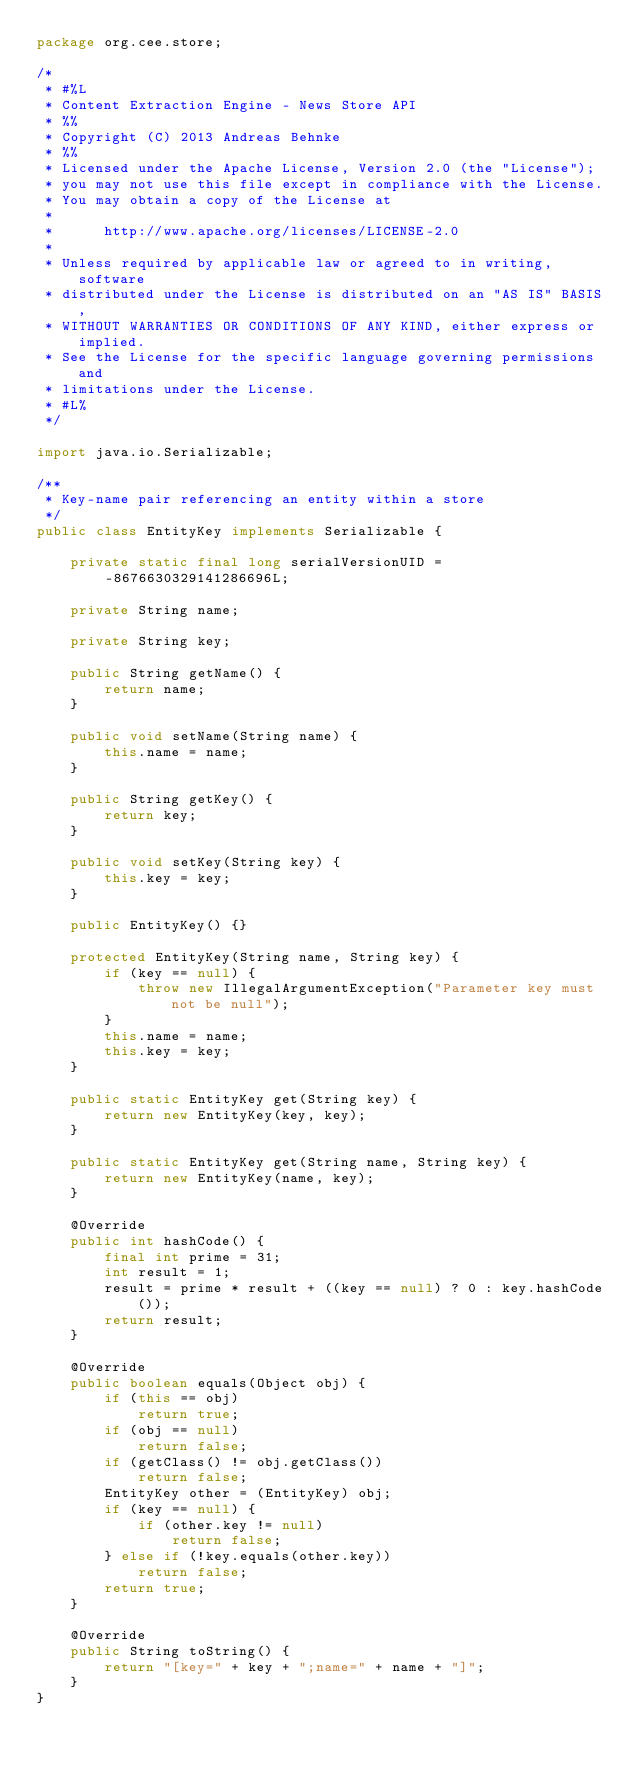Convert code to text. <code><loc_0><loc_0><loc_500><loc_500><_Java_>package org.cee.store;

/*
 * #%L
 * Content Extraction Engine - News Store API
 * %%
 * Copyright (C) 2013 Andreas Behnke
 * %%
 * Licensed under the Apache License, Version 2.0 (the "License");
 * you may not use this file except in compliance with the License.
 * You may obtain a copy of the License at
 * 
 *      http://www.apache.org/licenses/LICENSE-2.0
 * 
 * Unless required by applicable law or agreed to in writing, software
 * distributed under the License is distributed on an "AS IS" BASIS,
 * WITHOUT WARRANTIES OR CONDITIONS OF ANY KIND, either express or implied.
 * See the License for the specific language governing permissions and
 * limitations under the License.
 * #L%
 */

import java.io.Serializable;

/**
 * Key-name pair referencing an entity within a store
 */
public class EntityKey implements Serializable {
	
	private static final long serialVersionUID = -8676630329141286696L;
	
	private String name;
	
	private String key;
	
	public String getName() {
		return name;
	}

	public void setName(String name) {
		this.name = name;
	}

	public String getKey() {
		return key;
	}

	public void setKey(String key) {
		this.key = key;
	}
	
	public EntityKey() {}
	
	protected EntityKey(String name, String key) {
		if (key == null) {
			throw new IllegalArgumentException("Parameter key must not be null");
		}
		this.name = name;
		this.key = key;
	}
	
	public static EntityKey get(String key) {
	    return new EntityKey(key, key);
	}
	
	public static EntityKey get(String name, String key) {
        return new EntityKey(name, key);
    }
	
	@Override
	public int hashCode() {
		final int prime = 31;
		int result = 1;
		result = prime * result + ((key == null) ? 0 : key.hashCode());
		return result;
	}

	@Override
	public boolean equals(Object obj) {
		if (this == obj)
			return true;
		if (obj == null)
			return false;
		if (getClass() != obj.getClass())
			return false;
		EntityKey other = (EntityKey) obj;
		if (key == null) {
			if (other.key != null)
				return false;
		} else if (!key.equals(other.key))
			return false;
		return true;
	}

	@Override
	public String toString() {
		return "[key=" + key + ";name=" + name + "]";
	}
}
</code> 